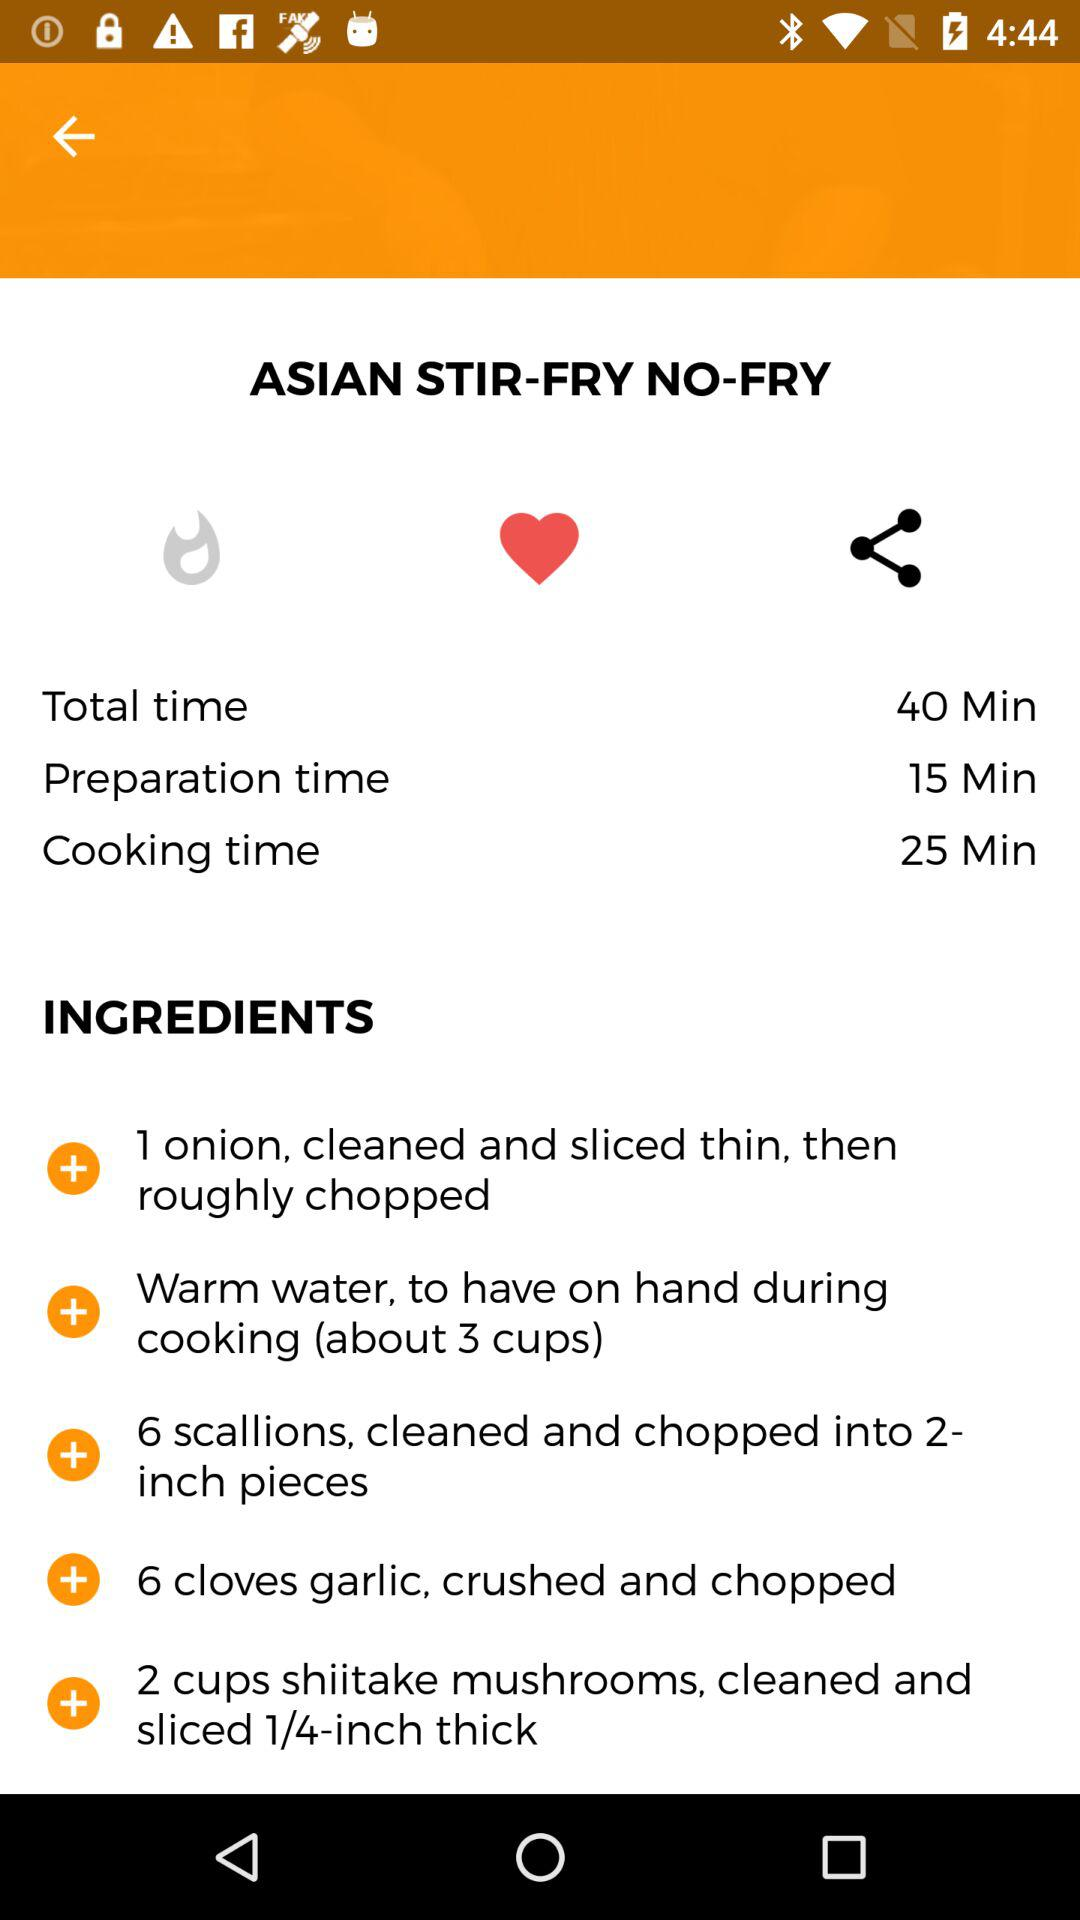How many cups of warm water are needed for this recipe?
Answer the question using a single word or phrase. 3 